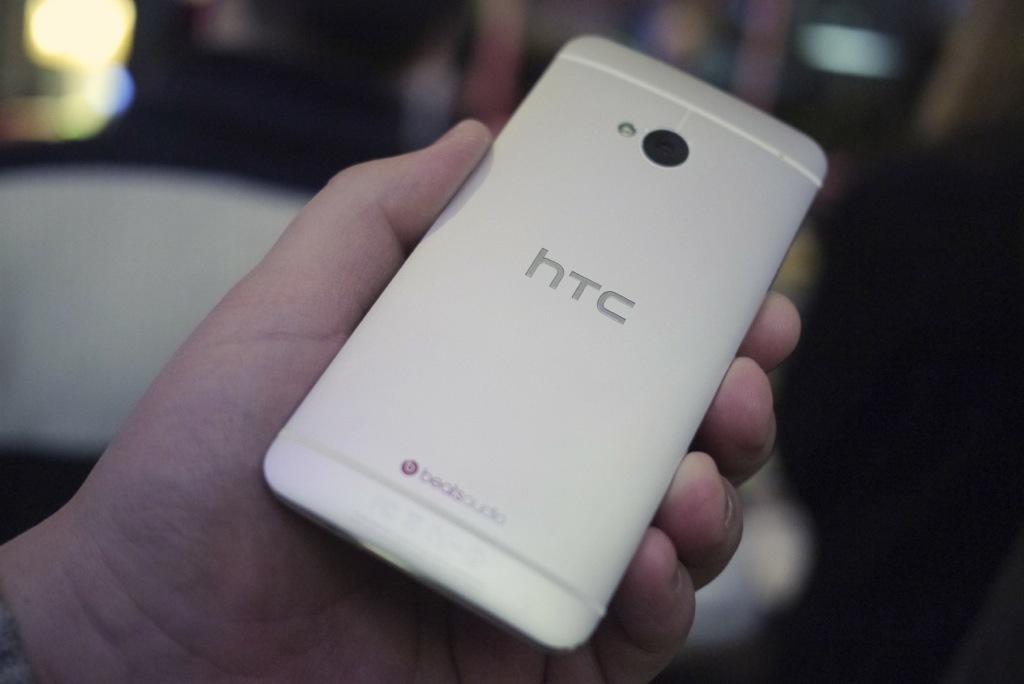What brand is this phone?
Give a very brief answer. Htc. 